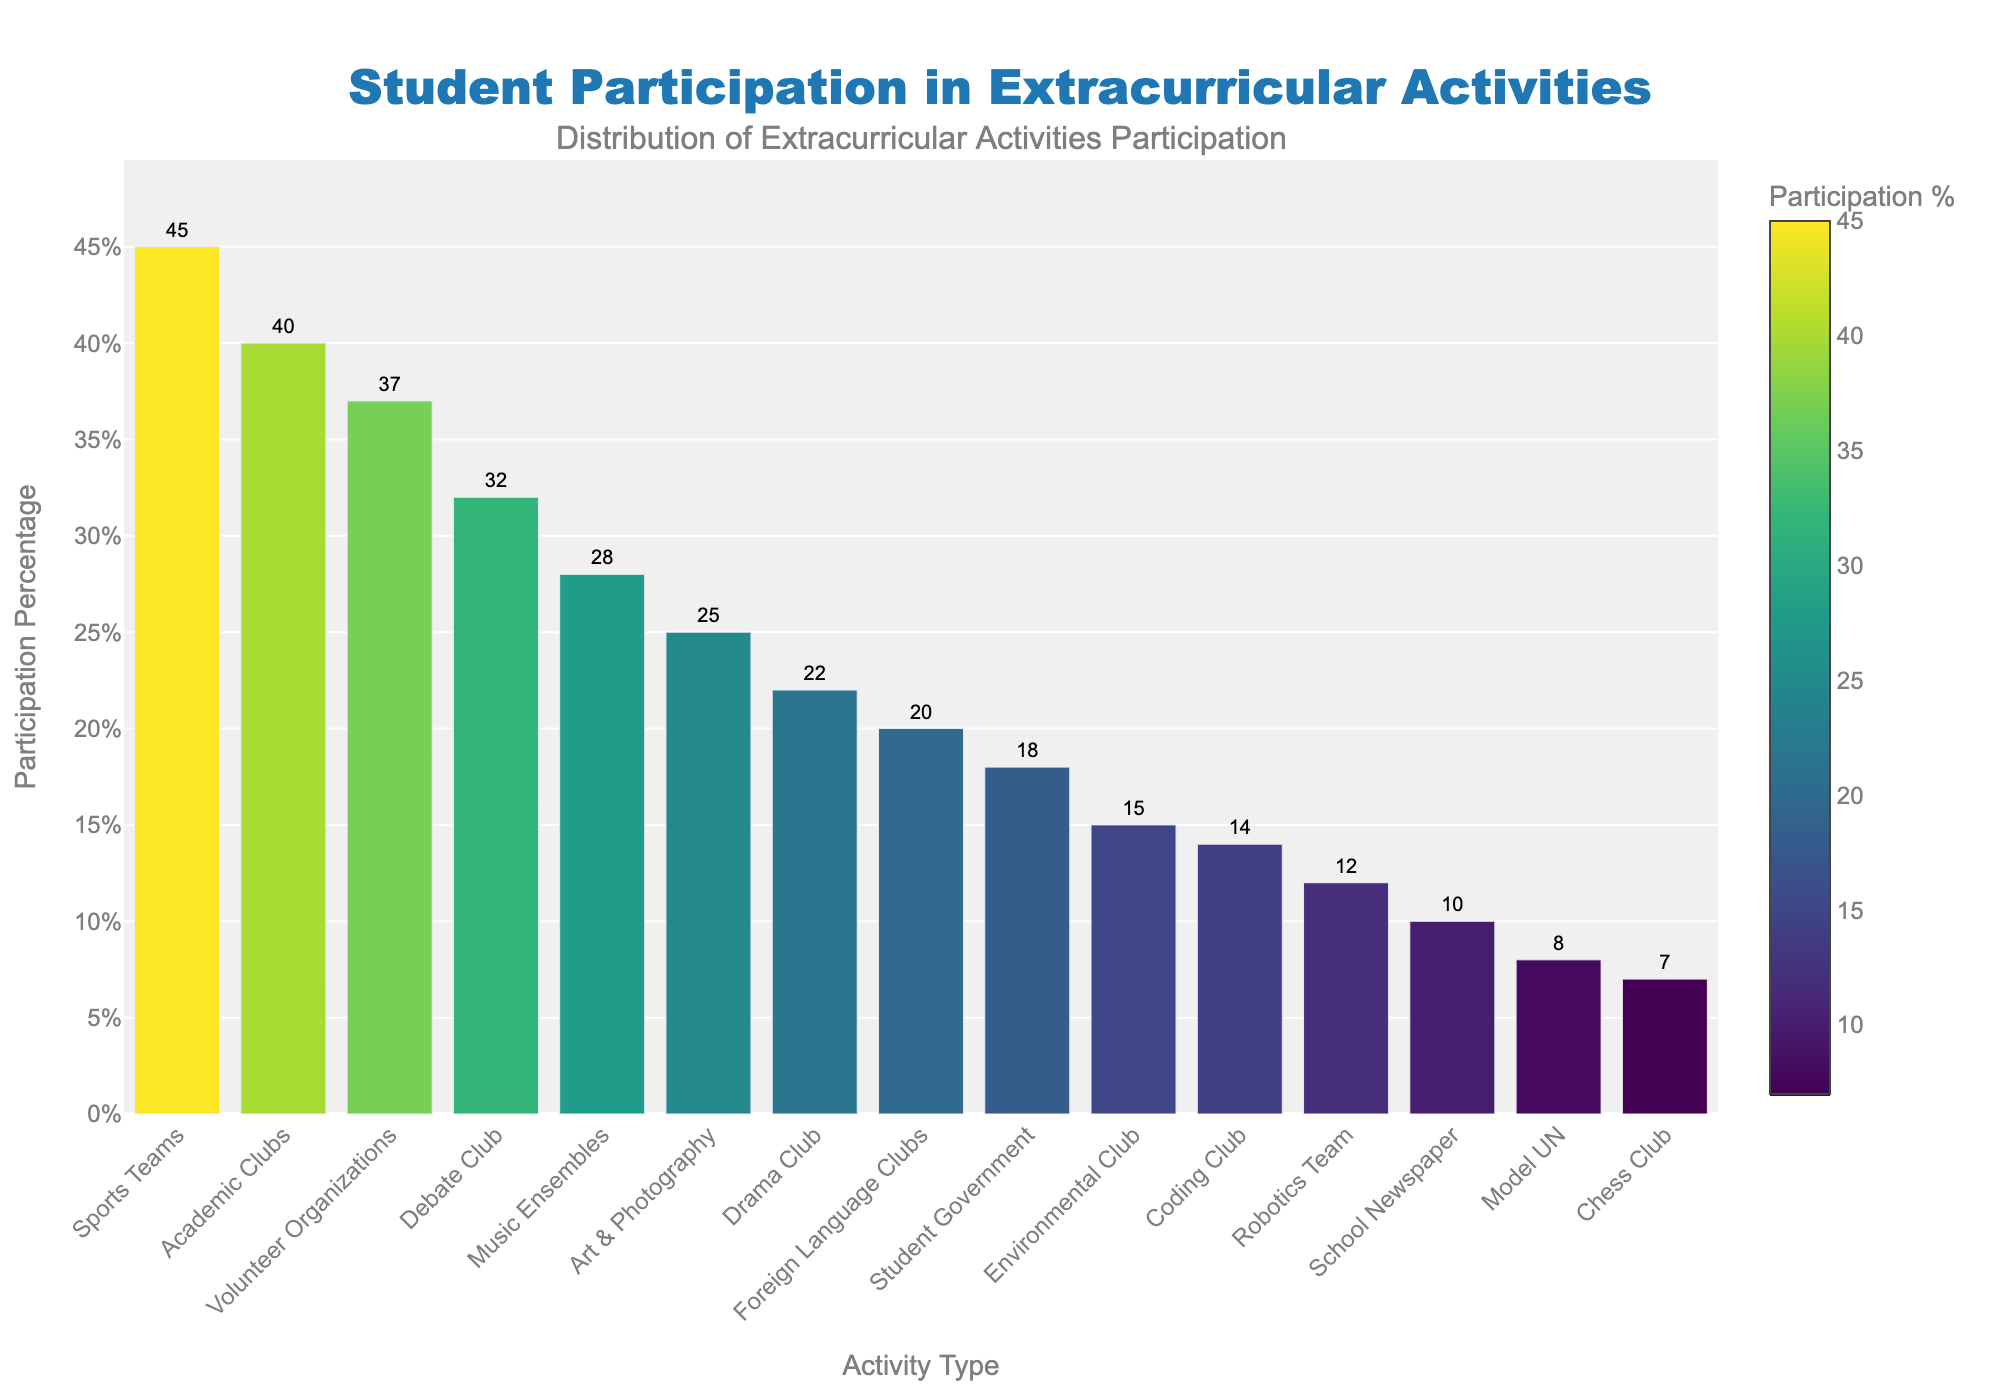Which activity has the highest participation percentage? The bar for Sports Teams is the tallest, indicating that it has the highest participation percentage.
Answer: Sports Teams Which activity has the lowest participation percentage? The bar for Model UN is the shortest, indicating that it has the lowest participation percentage.
Answer: Model UN How many activities have a participation percentage above 30%? The bars for Debate Club, Sports Teams, Volunteer Organizations, and Academic Clubs are higher than 30%. Counting these bars gives four activities.
Answer: 4 What's the difference in participation percentage between Sports Teams and Coding Club? The bar for Sports Teams is at 45%, and the bar for Coding Club is at 14%. Subtract 14 from 45: 45 - 14 = 31.
Answer: 31% Which activity has a higher participation percentage: Art & Photography or Drama Club? Compare the heights of the bars for Art & Photography (25%) and Drama Club (22%). Art & Photography has a higher participation percentage.
Answer: Art & Photography What is the average participation percentage for Debate Club, Music Ensembles, and Volunteer Organizations? Add the participation percentages: 32 + 28 + 37 = 97. Then divide by 3: 97 / 3 ≈ 32.33.
Answer: 32.33% Is the participation percentage of Environmental Club higher than 10%? The bar for Environmental Club reaches 15%, which is higher than 10%.
Answer: Yes Which has a greater participation percentage, Student Government or Foreign Language Clubs? Compare the heights of the bars for Student Government (18%) and Foreign Language Clubs (20%). Foreign Language Clubs has a higher participation percentage.
Answer: Foreign Language Clubs Are there more activities with participation percentages above or below 20%? Count the activities above 20%: Debate Club, Sports Teams, Music Ensembles, Drama Club, Volunteer Organizations, and Academic Clubs (6 activities). Count the activities below 20%: Student Government, Environmental Club, Foreign Language Clubs, Robotics Team, School Newspaper, Model UN, Chess Club, and Coding Club (8 activities). There are more activities below 20%.
Answer: Below 20% What is the total participation percentage for all activities combined? Sum all the participation percentages: 32 + 45 + 18 + 28 + 22 + 37 + 40 + 25 + 15 + 20 + 12 + 10 + 8 + 7 + 14 = 333.
Answer: 333% 